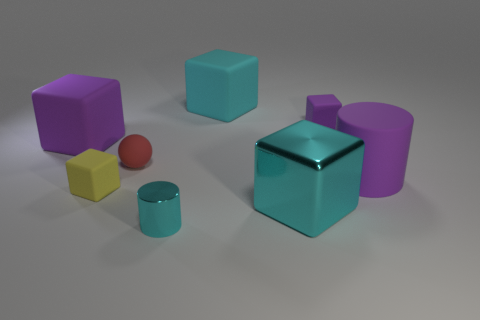Subtract all yellow blocks. How many blocks are left? 4 Add 2 small yellow cubes. How many objects exist? 10 Subtract all cylinders. How many objects are left? 6 Add 3 purple matte blocks. How many purple matte blocks are left? 5 Add 3 blue rubber objects. How many blue rubber objects exist? 3 Subtract 0 brown cubes. How many objects are left? 8 Subtract all small purple spheres. Subtract all matte cylinders. How many objects are left? 7 